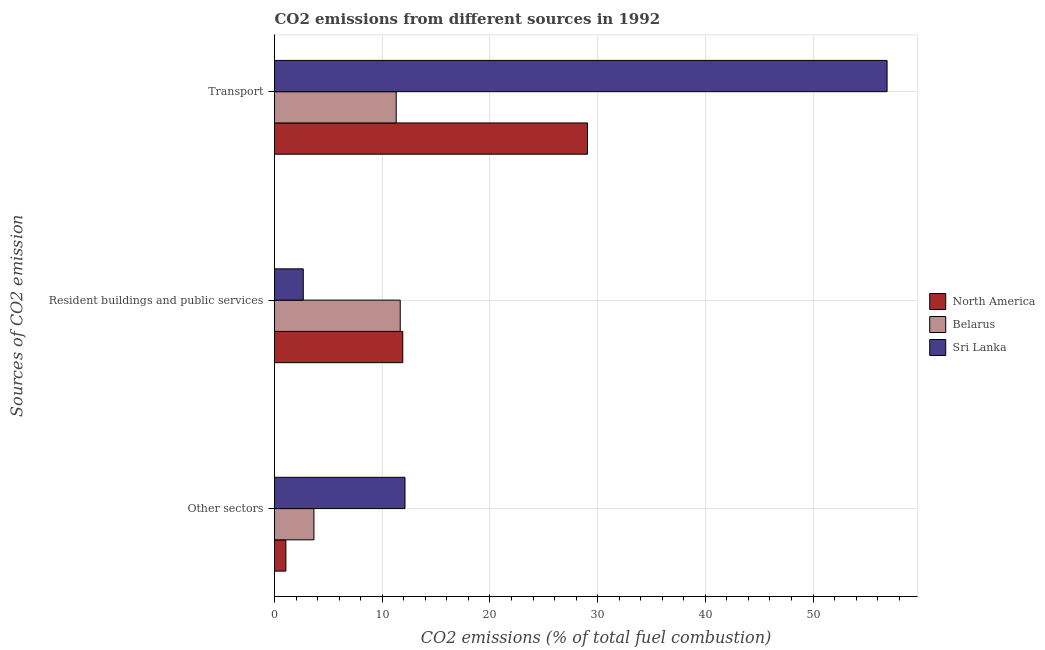How many groups of bars are there?
Provide a short and direct response. 3. Are the number of bars on each tick of the Y-axis equal?
Your response must be concise. Yes. How many bars are there on the 2nd tick from the top?
Provide a succinct answer. 3. What is the label of the 3rd group of bars from the top?
Give a very brief answer. Other sectors. What is the percentage of co2 emissions from resident buildings and public services in Belarus?
Offer a very short reply. 11.67. Across all countries, what is the maximum percentage of co2 emissions from resident buildings and public services?
Your answer should be very brief. 11.91. Across all countries, what is the minimum percentage of co2 emissions from transport?
Make the answer very short. 11.3. In which country was the percentage of co2 emissions from resident buildings and public services minimum?
Your answer should be compact. Sri Lanka. What is the total percentage of co2 emissions from resident buildings and public services in the graph?
Provide a succinct answer. 26.25. What is the difference between the percentage of co2 emissions from resident buildings and public services in Sri Lanka and that in North America?
Ensure brevity in your answer.  -9.24. What is the difference between the percentage of co2 emissions from other sectors in North America and the percentage of co2 emissions from transport in Sri Lanka?
Ensure brevity in your answer.  -55.82. What is the average percentage of co2 emissions from other sectors per country?
Offer a very short reply. 5.61. What is the difference between the percentage of co2 emissions from resident buildings and public services and percentage of co2 emissions from transport in North America?
Ensure brevity in your answer.  -17.15. In how many countries, is the percentage of co2 emissions from transport greater than 4 %?
Provide a succinct answer. 3. What is the ratio of the percentage of co2 emissions from resident buildings and public services in Sri Lanka to that in Belarus?
Keep it short and to the point. 0.23. What is the difference between the highest and the second highest percentage of co2 emissions from other sectors?
Offer a terse response. 8.46. What is the difference between the highest and the lowest percentage of co2 emissions from resident buildings and public services?
Your response must be concise. 9.24. In how many countries, is the percentage of co2 emissions from transport greater than the average percentage of co2 emissions from transport taken over all countries?
Give a very brief answer. 1. What does the 2nd bar from the top in Other sectors represents?
Offer a terse response. Belarus. What does the 3rd bar from the bottom in Transport represents?
Provide a succinct answer. Sri Lanka. Is it the case that in every country, the sum of the percentage of co2 emissions from other sectors and percentage of co2 emissions from resident buildings and public services is greater than the percentage of co2 emissions from transport?
Your answer should be very brief. No. Does the graph contain grids?
Give a very brief answer. Yes. Where does the legend appear in the graph?
Ensure brevity in your answer.  Center right. How many legend labels are there?
Offer a terse response. 3. How are the legend labels stacked?
Ensure brevity in your answer.  Vertical. What is the title of the graph?
Ensure brevity in your answer.  CO2 emissions from different sources in 1992. What is the label or title of the X-axis?
Ensure brevity in your answer.  CO2 emissions (% of total fuel combustion). What is the label or title of the Y-axis?
Your response must be concise. Sources of CO2 emission. What is the CO2 emissions (% of total fuel combustion) of North America in Other sectors?
Ensure brevity in your answer.  1.05. What is the CO2 emissions (% of total fuel combustion) of Belarus in Other sectors?
Keep it short and to the point. 3.66. What is the CO2 emissions (% of total fuel combustion) of Sri Lanka in Other sectors?
Your answer should be very brief. 12.11. What is the CO2 emissions (% of total fuel combustion) in North America in Resident buildings and public services?
Provide a short and direct response. 11.91. What is the CO2 emissions (% of total fuel combustion) of Belarus in Resident buildings and public services?
Your response must be concise. 11.67. What is the CO2 emissions (% of total fuel combustion) in Sri Lanka in Resident buildings and public services?
Your answer should be very brief. 2.67. What is the CO2 emissions (% of total fuel combustion) in North America in Transport?
Make the answer very short. 29.06. What is the CO2 emissions (% of total fuel combustion) of Belarus in Transport?
Your answer should be compact. 11.3. What is the CO2 emissions (% of total fuel combustion) in Sri Lanka in Transport?
Provide a succinct answer. 56.88. Across all Sources of CO2 emission, what is the maximum CO2 emissions (% of total fuel combustion) of North America?
Provide a short and direct response. 29.06. Across all Sources of CO2 emission, what is the maximum CO2 emissions (% of total fuel combustion) in Belarus?
Your answer should be compact. 11.67. Across all Sources of CO2 emission, what is the maximum CO2 emissions (% of total fuel combustion) of Sri Lanka?
Keep it short and to the point. 56.88. Across all Sources of CO2 emission, what is the minimum CO2 emissions (% of total fuel combustion) of North America?
Keep it short and to the point. 1.05. Across all Sources of CO2 emission, what is the minimum CO2 emissions (% of total fuel combustion) of Belarus?
Provide a short and direct response. 3.66. Across all Sources of CO2 emission, what is the minimum CO2 emissions (% of total fuel combustion) in Sri Lanka?
Offer a terse response. 2.67. What is the total CO2 emissions (% of total fuel combustion) in North America in the graph?
Your answer should be very brief. 42.03. What is the total CO2 emissions (% of total fuel combustion) of Belarus in the graph?
Provide a succinct answer. 26.63. What is the total CO2 emissions (% of total fuel combustion) in Sri Lanka in the graph?
Make the answer very short. 71.66. What is the difference between the CO2 emissions (% of total fuel combustion) in North America in Other sectors and that in Resident buildings and public services?
Give a very brief answer. -10.86. What is the difference between the CO2 emissions (% of total fuel combustion) in Belarus in Other sectors and that in Resident buildings and public services?
Provide a short and direct response. -8.01. What is the difference between the CO2 emissions (% of total fuel combustion) in Sri Lanka in Other sectors and that in Resident buildings and public services?
Provide a succinct answer. 9.45. What is the difference between the CO2 emissions (% of total fuel combustion) of North America in Other sectors and that in Transport?
Your answer should be very brief. -28.01. What is the difference between the CO2 emissions (% of total fuel combustion) in Belarus in Other sectors and that in Transport?
Provide a short and direct response. -7.64. What is the difference between the CO2 emissions (% of total fuel combustion) of Sri Lanka in Other sectors and that in Transport?
Your answer should be very brief. -44.76. What is the difference between the CO2 emissions (% of total fuel combustion) in North America in Resident buildings and public services and that in Transport?
Give a very brief answer. -17.15. What is the difference between the CO2 emissions (% of total fuel combustion) in Belarus in Resident buildings and public services and that in Transport?
Your answer should be very brief. 0.37. What is the difference between the CO2 emissions (% of total fuel combustion) of Sri Lanka in Resident buildings and public services and that in Transport?
Provide a short and direct response. -54.21. What is the difference between the CO2 emissions (% of total fuel combustion) in North America in Other sectors and the CO2 emissions (% of total fuel combustion) in Belarus in Resident buildings and public services?
Provide a succinct answer. -10.62. What is the difference between the CO2 emissions (% of total fuel combustion) in North America in Other sectors and the CO2 emissions (% of total fuel combustion) in Sri Lanka in Resident buildings and public services?
Provide a short and direct response. -1.62. What is the difference between the CO2 emissions (% of total fuel combustion) in North America in Other sectors and the CO2 emissions (% of total fuel combustion) in Belarus in Transport?
Give a very brief answer. -10.25. What is the difference between the CO2 emissions (% of total fuel combustion) of North America in Other sectors and the CO2 emissions (% of total fuel combustion) of Sri Lanka in Transport?
Give a very brief answer. -55.83. What is the difference between the CO2 emissions (% of total fuel combustion) in Belarus in Other sectors and the CO2 emissions (% of total fuel combustion) in Sri Lanka in Transport?
Offer a terse response. -53.22. What is the difference between the CO2 emissions (% of total fuel combustion) in North America in Resident buildings and public services and the CO2 emissions (% of total fuel combustion) in Belarus in Transport?
Ensure brevity in your answer.  0.61. What is the difference between the CO2 emissions (% of total fuel combustion) in North America in Resident buildings and public services and the CO2 emissions (% of total fuel combustion) in Sri Lanka in Transport?
Your answer should be very brief. -44.97. What is the difference between the CO2 emissions (% of total fuel combustion) in Belarus in Resident buildings and public services and the CO2 emissions (% of total fuel combustion) in Sri Lanka in Transport?
Keep it short and to the point. -45.21. What is the average CO2 emissions (% of total fuel combustion) of North America per Sources of CO2 emission?
Keep it short and to the point. 14.01. What is the average CO2 emissions (% of total fuel combustion) of Belarus per Sources of CO2 emission?
Your answer should be compact. 8.88. What is the average CO2 emissions (% of total fuel combustion) in Sri Lanka per Sources of CO2 emission?
Your answer should be compact. 23.89. What is the difference between the CO2 emissions (% of total fuel combustion) of North America and CO2 emissions (% of total fuel combustion) of Belarus in Other sectors?
Offer a terse response. -2.6. What is the difference between the CO2 emissions (% of total fuel combustion) in North America and CO2 emissions (% of total fuel combustion) in Sri Lanka in Other sectors?
Keep it short and to the point. -11.06. What is the difference between the CO2 emissions (% of total fuel combustion) of Belarus and CO2 emissions (% of total fuel combustion) of Sri Lanka in Other sectors?
Your answer should be compact. -8.46. What is the difference between the CO2 emissions (% of total fuel combustion) of North America and CO2 emissions (% of total fuel combustion) of Belarus in Resident buildings and public services?
Ensure brevity in your answer.  0.24. What is the difference between the CO2 emissions (% of total fuel combustion) in North America and CO2 emissions (% of total fuel combustion) in Sri Lanka in Resident buildings and public services?
Provide a short and direct response. 9.24. What is the difference between the CO2 emissions (% of total fuel combustion) in Belarus and CO2 emissions (% of total fuel combustion) in Sri Lanka in Resident buildings and public services?
Your answer should be compact. 9. What is the difference between the CO2 emissions (% of total fuel combustion) in North America and CO2 emissions (% of total fuel combustion) in Belarus in Transport?
Your response must be concise. 17.76. What is the difference between the CO2 emissions (% of total fuel combustion) of North America and CO2 emissions (% of total fuel combustion) of Sri Lanka in Transport?
Make the answer very short. -27.82. What is the difference between the CO2 emissions (% of total fuel combustion) of Belarus and CO2 emissions (% of total fuel combustion) of Sri Lanka in Transport?
Your answer should be compact. -45.58. What is the ratio of the CO2 emissions (% of total fuel combustion) of North America in Other sectors to that in Resident buildings and public services?
Offer a terse response. 0.09. What is the ratio of the CO2 emissions (% of total fuel combustion) of Belarus in Other sectors to that in Resident buildings and public services?
Provide a short and direct response. 0.31. What is the ratio of the CO2 emissions (% of total fuel combustion) in Sri Lanka in Other sectors to that in Resident buildings and public services?
Your response must be concise. 4.54. What is the ratio of the CO2 emissions (% of total fuel combustion) in North America in Other sectors to that in Transport?
Your response must be concise. 0.04. What is the ratio of the CO2 emissions (% of total fuel combustion) in Belarus in Other sectors to that in Transport?
Your answer should be very brief. 0.32. What is the ratio of the CO2 emissions (% of total fuel combustion) of Sri Lanka in Other sectors to that in Transport?
Make the answer very short. 0.21. What is the ratio of the CO2 emissions (% of total fuel combustion) in North America in Resident buildings and public services to that in Transport?
Your answer should be compact. 0.41. What is the ratio of the CO2 emissions (% of total fuel combustion) in Belarus in Resident buildings and public services to that in Transport?
Ensure brevity in your answer.  1.03. What is the ratio of the CO2 emissions (% of total fuel combustion) in Sri Lanka in Resident buildings and public services to that in Transport?
Your response must be concise. 0.05. What is the difference between the highest and the second highest CO2 emissions (% of total fuel combustion) in North America?
Provide a short and direct response. 17.15. What is the difference between the highest and the second highest CO2 emissions (% of total fuel combustion) in Belarus?
Provide a succinct answer. 0.37. What is the difference between the highest and the second highest CO2 emissions (% of total fuel combustion) of Sri Lanka?
Provide a succinct answer. 44.76. What is the difference between the highest and the lowest CO2 emissions (% of total fuel combustion) in North America?
Make the answer very short. 28.01. What is the difference between the highest and the lowest CO2 emissions (% of total fuel combustion) in Belarus?
Your response must be concise. 8.01. What is the difference between the highest and the lowest CO2 emissions (% of total fuel combustion) in Sri Lanka?
Offer a very short reply. 54.21. 